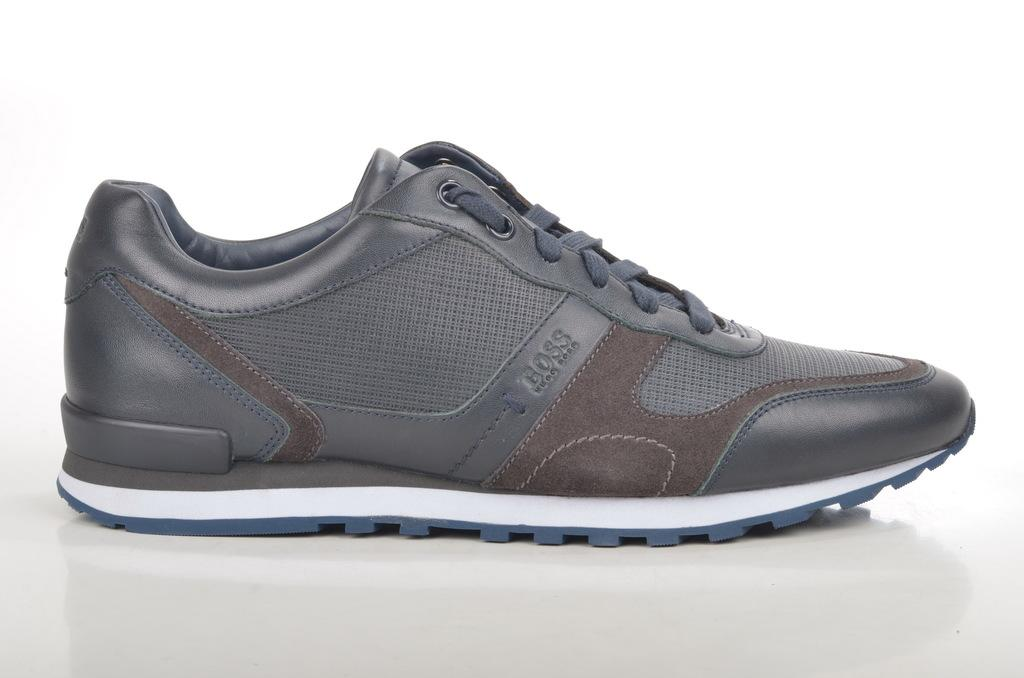What type of object is present in the image? The image contains a shoe. Can you see a wound on the shoe in the image? There is no mention of a wound in the provided facts, and therefore it cannot be determined if a wound is present on the shoe in the image. 